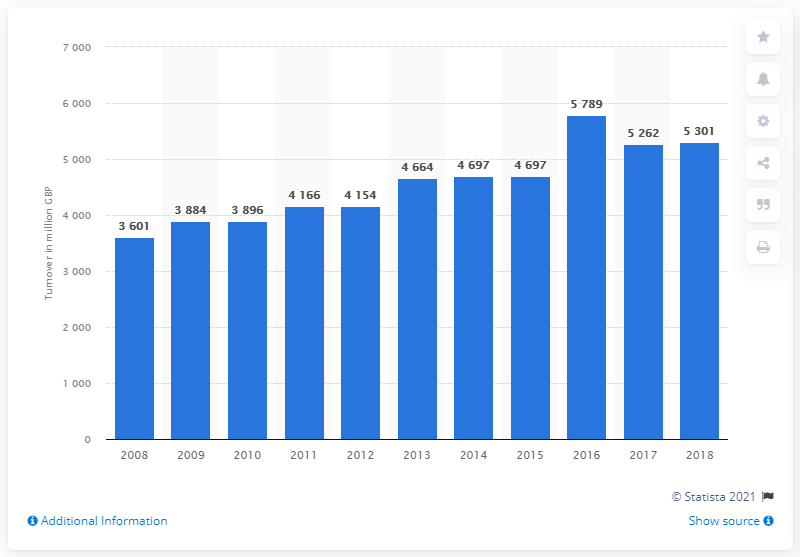Mention a couple of crucial points in this snapshot. The turnover from pet product sales in the UK in 2010 was 3896. The turnover from pet product sales in the UK in 2018 was approximately £5301 million. 